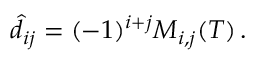<formula> <loc_0><loc_0><loc_500><loc_500>\begin{array} { r } { \hat { d } _ { i j } = ( - 1 ) ^ { i + j } M _ { i , j } ( T ) \, . } \end{array}</formula> 